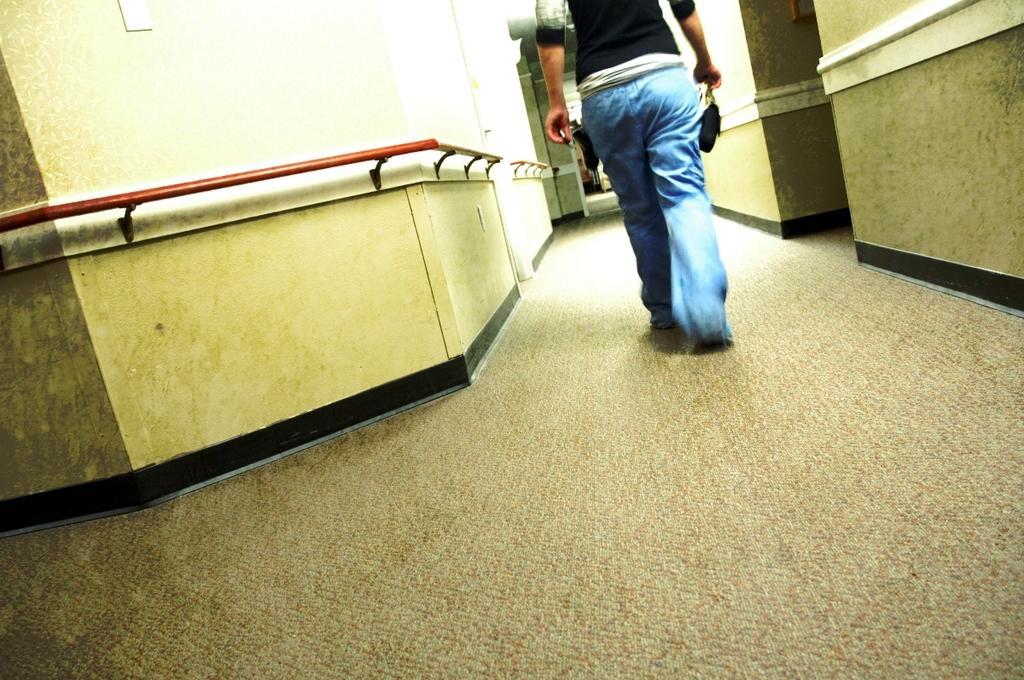Can you describe this image briefly? In this picture we can see a person is walking on the path and on the left side of the people there is a wall with rods. 